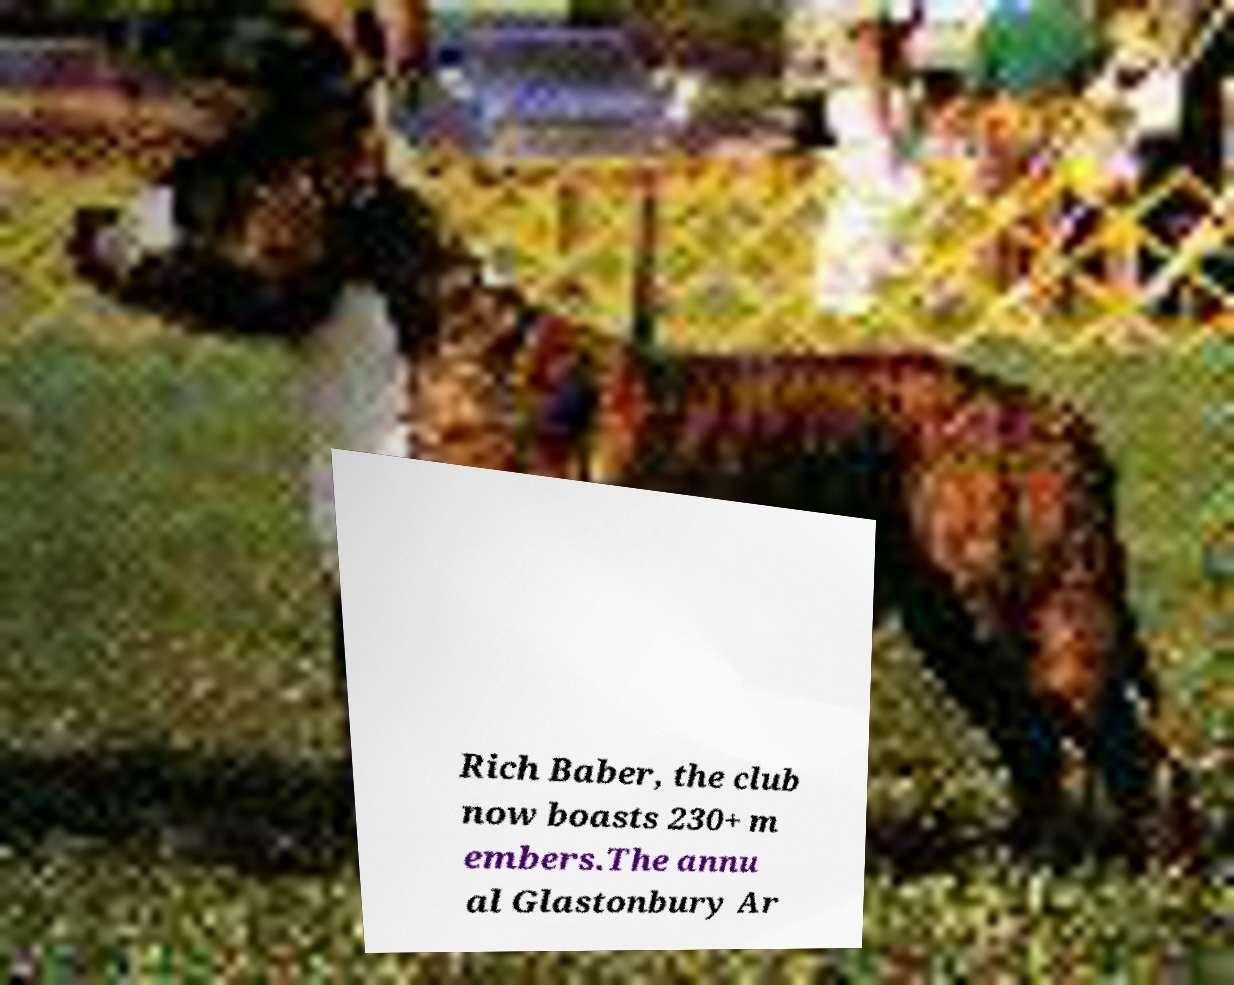There's text embedded in this image that I need extracted. Can you transcribe it verbatim? Rich Baber, the club now boasts 230+ m embers.The annu al Glastonbury Ar 